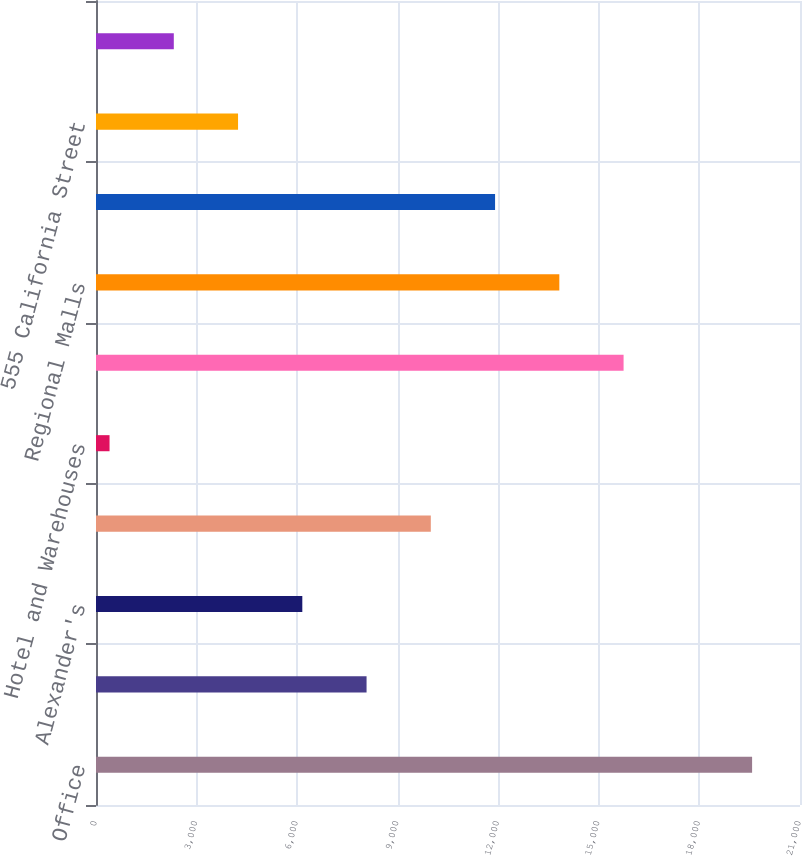<chart> <loc_0><loc_0><loc_500><loc_500><bar_chart><fcel>Office<fcel>Retail<fcel>Alexander's<fcel>Residential (2414 units)<fcel>Hotel and Warehouses<fcel>Strip Shopping Centers<fcel>Regional Malls<fcel>Showroom<fcel>555 California Street<fcel>Primarily Warehouses<nl><fcel>19571<fcel>8070.8<fcel>6154.1<fcel>9987.5<fcel>404<fcel>15737.6<fcel>13820.9<fcel>11904.2<fcel>4237.4<fcel>2320.7<nl></chart> 